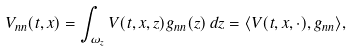<formula> <loc_0><loc_0><loc_500><loc_500>V _ { n n } ( t , x ) = \int _ { \omega _ { z } } V ( t , x , z ) g _ { n n } ( z ) \, d z = \langle V ( t , x , \cdot ) , g _ { n n } \rangle ,</formula> 